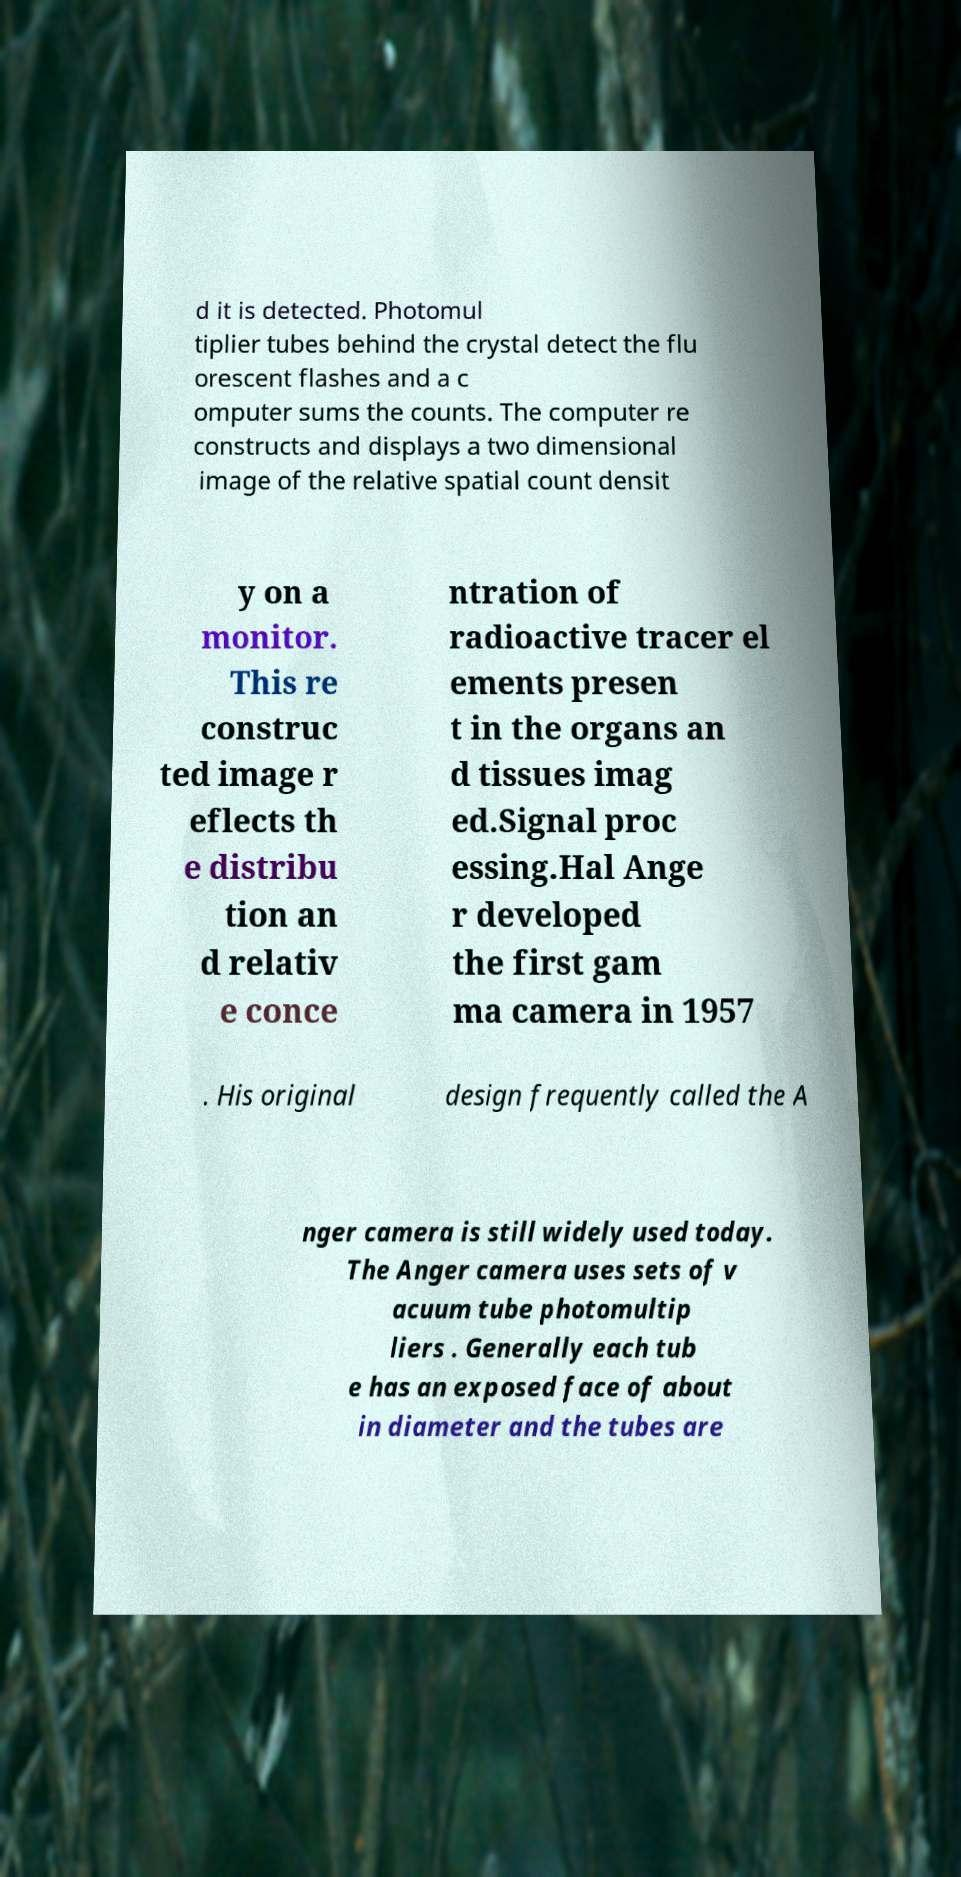There's text embedded in this image that I need extracted. Can you transcribe it verbatim? d it is detected. Photomul tiplier tubes behind the crystal detect the flu orescent flashes and a c omputer sums the counts. The computer re constructs and displays a two dimensional image of the relative spatial count densit y on a monitor. This re construc ted image r eflects th e distribu tion an d relativ e conce ntration of radioactive tracer el ements presen t in the organs an d tissues imag ed.Signal proc essing.Hal Ange r developed the first gam ma camera in 1957 . His original design frequently called the A nger camera is still widely used today. The Anger camera uses sets of v acuum tube photomultip liers . Generally each tub e has an exposed face of about in diameter and the tubes are 